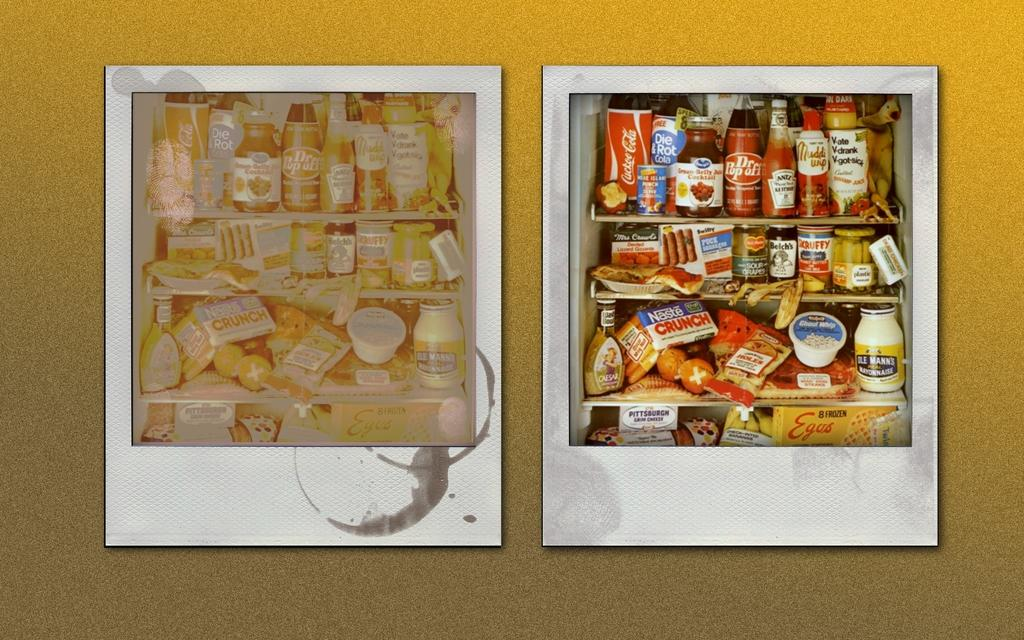<image>
Offer a succinct explanation of the picture presented. Two polaroids of shelves with many pantry items on them such as Dr. Pop Off and a Nestle Crunch. 